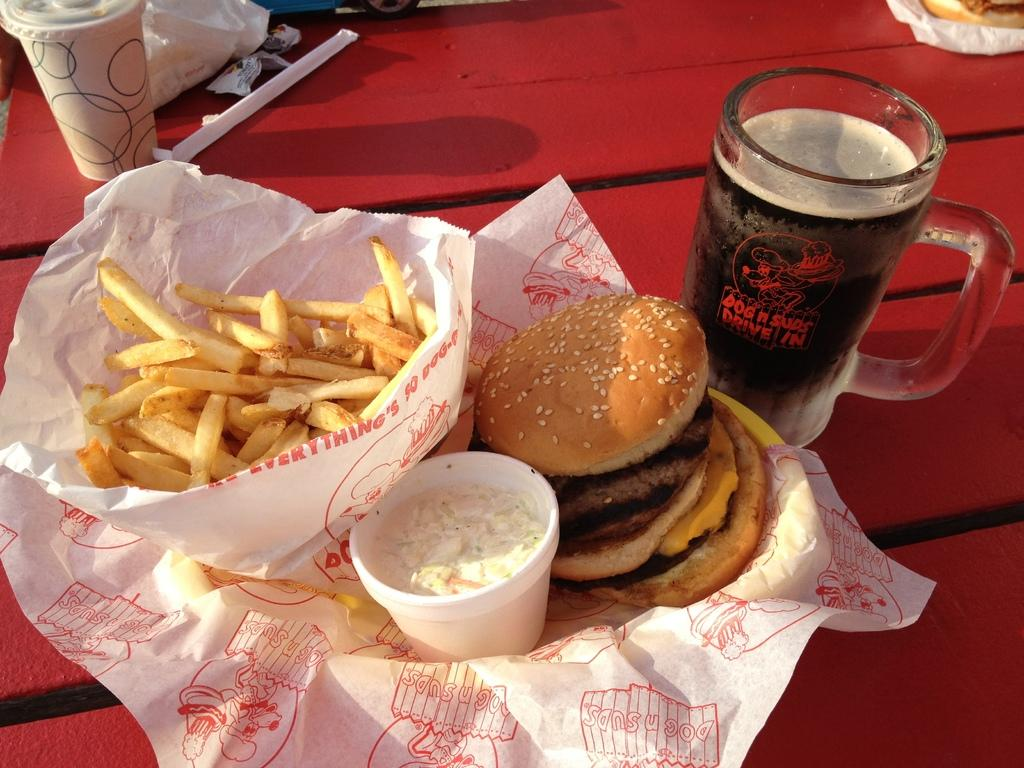What type of food can be seen in the image? There are burgers and french fries in the image. What beverage might be in the glass mug? There is a glass mug with some liquid in the image, but the specific beverage is not identifiable. What other objects are present on the tables in the image? There are other objects on the tables in the image, but their specific details are not provided. What type of destruction can be seen in the image? There is no destruction present in the image; it features burgers, french fries, a glass mug with liquid, and other objects on the tables. Can you tell me how many bags of popcorn are on the tables in the image? There is no popcorn present in the image; it features burgers, french fries, a glass mug with liquid, and other objects on the tables. 